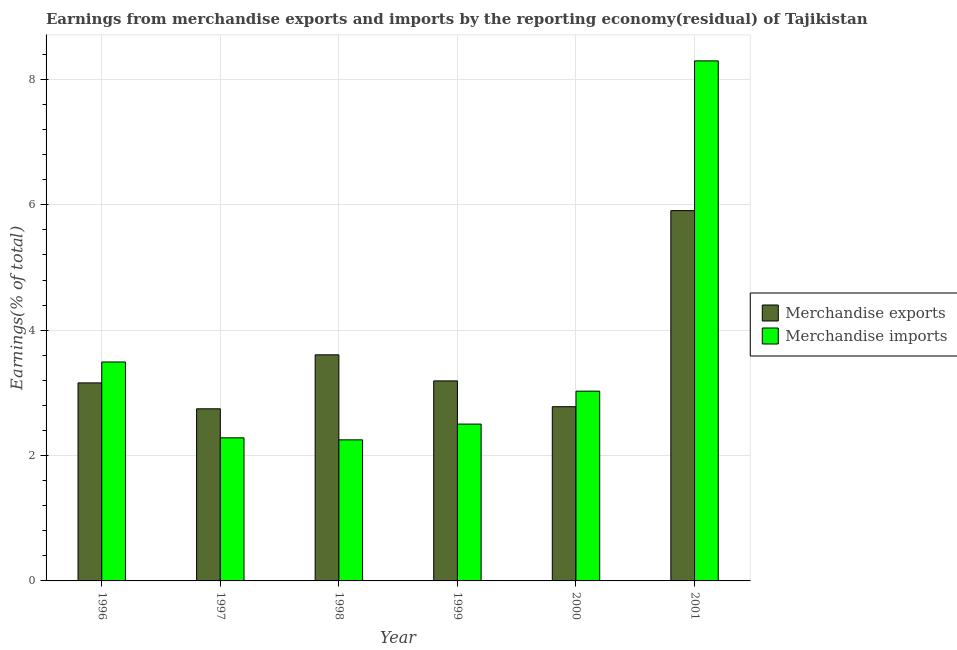How many different coloured bars are there?
Your answer should be compact. 2. How many groups of bars are there?
Offer a very short reply. 6. Are the number of bars per tick equal to the number of legend labels?
Ensure brevity in your answer.  Yes. Are the number of bars on each tick of the X-axis equal?
Your answer should be very brief. Yes. How many bars are there on the 4th tick from the left?
Give a very brief answer. 2. How many bars are there on the 5th tick from the right?
Keep it short and to the point. 2. What is the label of the 6th group of bars from the left?
Offer a terse response. 2001. What is the earnings from merchandise exports in 1999?
Offer a terse response. 3.19. Across all years, what is the maximum earnings from merchandise exports?
Provide a succinct answer. 5.91. Across all years, what is the minimum earnings from merchandise imports?
Your answer should be compact. 2.25. In which year was the earnings from merchandise exports maximum?
Offer a very short reply. 2001. In which year was the earnings from merchandise imports minimum?
Give a very brief answer. 1998. What is the total earnings from merchandise exports in the graph?
Offer a very short reply. 21.39. What is the difference between the earnings from merchandise exports in 1996 and that in 1999?
Ensure brevity in your answer.  -0.03. What is the difference between the earnings from merchandise imports in 2000 and the earnings from merchandise exports in 1998?
Your answer should be compact. 0.78. What is the average earnings from merchandise imports per year?
Your answer should be very brief. 3.64. In the year 1998, what is the difference between the earnings from merchandise imports and earnings from merchandise exports?
Offer a terse response. 0. In how many years, is the earnings from merchandise exports greater than 6.8 %?
Provide a succinct answer. 0. What is the ratio of the earnings from merchandise imports in 1997 to that in 2001?
Give a very brief answer. 0.28. What is the difference between the highest and the second highest earnings from merchandise imports?
Your answer should be very brief. 4.8. What is the difference between the highest and the lowest earnings from merchandise exports?
Offer a terse response. 3.16. In how many years, is the earnings from merchandise exports greater than the average earnings from merchandise exports taken over all years?
Ensure brevity in your answer.  2. What does the 2nd bar from the left in 1999 represents?
Give a very brief answer. Merchandise imports. What does the 2nd bar from the right in 1999 represents?
Offer a very short reply. Merchandise exports. How many bars are there?
Keep it short and to the point. 12. Are all the bars in the graph horizontal?
Your response must be concise. No. What is the difference between two consecutive major ticks on the Y-axis?
Ensure brevity in your answer.  2. Does the graph contain grids?
Provide a succinct answer. Yes. Where does the legend appear in the graph?
Offer a terse response. Center right. How are the legend labels stacked?
Give a very brief answer. Vertical. What is the title of the graph?
Offer a very short reply. Earnings from merchandise exports and imports by the reporting economy(residual) of Tajikistan. Does "Male" appear as one of the legend labels in the graph?
Offer a terse response. No. What is the label or title of the X-axis?
Provide a succinct answer. Year. What is the label or title of the Y-axis?
Offer a very short reply. Earnings(% of total). What is the Earnings(% of total) in Merchandise exports in 1996?
Your response must be concise. 3.16. What is the Earnings(% of total) of Merchandise imports in 1996?
Offer a terse response. 3.49. What is the Earnings(% of total) of Merchandise exports in 1997?
Ensure brevity in your answer.  2.75. What is the Earnings(% of total) in Merchandise imports in 1997?
Your answer should be very brief. 2.28. What is the Earnings(% of total) of Merchandise exports in 1998?
Keep it short and to the point. 3.61. What is the Earnings(% of total) of Merchandise imports in 1998?
Provide a succinct answer. 2.25. What is the Earnings(% of total) in Merchandise exports in 1999?
Ensure brevity in your answer.  3.19. What is the Earnings(% of total) in Merchandise imports in 1999?
Provide a short and direct response. 2.5. What is the Earnings(% of total) of Merchandise exports in 2000?
Offer a terse response. 2.78. What is the Earnings(% of total) in Merchandise imports in 2000?
Give a very brief answer. 3.03. What is the Earnings(% of total) in Merchandise exports in 2001?
Offer a terse response. 5.91. What is the Earnings(% of total) in Merchandise imports in 2001?
Your answer should be compact. 8.3. Across all years, what is the maximum Earnings(% of total) in Merchandise exports?
Offer a terse response. 5.91. Across all years, what is the maximum Earnings(% of total) in Merchandise imports?
Your answer should be compact. 8.3. Across all years, what is the minimum Earnings(% of total) in Merchandise exports?
Keep it short and to the point. 2.75. Across all years, what is the minimum Earnings(% of total) of Merchandise imports?
Your answer should be very brief. 2.25. What is the total Earnings(% of total) of Merchandise exports in the graph?
Your answer should be very brief. 21.39. What is the total Earnings(% of total) of Merchandise imports in the graph?
Offer a very short reply. 21.85. What is the difference between the Earnings(% of total) in Merchandise exports in 1996 and that in 1997?
Provide a succinct answer. 0.41. What is the difference between the Earnings(% of total) in Merchandise imports in 1996 and that in 1997?
Provide a short and direct response. 1.21. What is the difference between the Earnings(% of total) in Merchandise exports in 1996 and that in 1998?
Give a very brief answer. -0.45. What is the difference between the Earnings(% of total) of Merchandise imports in 1996 and that in 1998?
Your answer should be compact. 1.24. What is the difference between the Earnings(% of total) in Merchandise exports in 1996 and that in 1999?
Ensure brevity in your answer.  -0.03. What is the difference between the Earnings(% of total) of Merchandise imports in 1996 and that in 1999?
Make the answer very short. 0.99. What is the difference between the Earnings(% of total) of Merchandise exports in 1996 and that in 2000?
Offer a terse response. 0.38. What is the difference between the Earnings(% of total) of Merchandise imports in 1996 and that in 2000?
Offer a very short reply. 0.47. What is the difference between the Earnings(% of total) in Merchandise exports in 1996 and that in 2001?
Give a very brief answer. -2.75. What is the difference between the Earnings(% of total) in Merchandise imports in 1996 and that in 2001?
Your answer should be compact. -4.8. What is the difference between the Earnings(% of total) of Merchandise exports in 1997 and that in 1998?
Offer a terse response. -0.86. What is the difference between the Earnings(% of total) of Merchandise imports in 1997 and that in 1998?
Offer a terse response. 0.03. What is the difference between the Earnings(% of total) in Merchandise exports in 1997 and that in 1999?
Ensure brevity in your answer.  -0.45. What is the difference between the Earnings(% of total) in Merchandise imports in 1997 and that in 1999?
Provide a short and direct response. -0.22. What is the difference between the Earnings(% of total) of Merchandise exports in 1997 and that in 2000?
Offer a very short reply. -0.03. What is the difference between the Earnings(% of total) in Merchandise imports in 1997 and that in 2000?
Your response must be concise. -0.74. What is the difference between the Earnings(% of total) of Merchandise exports in 1997 and that in 2001?
Give a very brief answer. -3.16. What is the difference between the Earnings(% of total) of Merchandise imports in 1997 and that in 2001?
Offer a very short reply. -6.01. What is the difference between the Earnings(% of total) of Merchandise exports in 1998 and that in 1999?
Provide a short and direct response. 0.42. What is the difference between the Earnings(% of total) of Merchandise imports in 1998 and that in 1999?
Give a very brief answer. -0.25. What is the difference between the Earnings(% of total) in Merchandise exports in 1998 and that in 2000?
Your answer should be very brief. 0.83. What is the difference between the Earnings(% of total) of Merchandise imports in 1998 and that in 2000?
Ensure brevity in your answer.  -0.78. What is the difference between the Earnings(% of total) in Merchandise exports in 1998 and that in 2001?
Your response must be concise. -2.3. What is the difference between the Earnings(% of total) of Merchandise imports in 1998 and that in 2001?
Your answer should be compact. -6.05. What is the difference between the Earnings(% of total) of Merchandise exports in 1999 and that in 2000?
Your answer should be compact. 0.41. What is the difference between the Earnings(% of total) in Merchandise imports in 1999 and that in 2000?
Ensure brevity in your answer.  -0.53. What is the difference between the Earnings(% of total) of Merchandise exports in 1999 and that in 2001?
Make the answer very short. -2.72. What is the difference between the Earnings(% of total) of Merchandise imports in 1999 and that in 2001?
Make the answer very short. -5.79. What is the difference between the Earnings(% of total) in Merchandise exports in 2000 and that in 2001?
Keep it short and to the point. -3.13. What is the difference between the Earnings(% of total) of Merchandise imports in 2000 and that in 2001?
Your answer should be compact. -5.27. What is the difference between the Earnings(% of total) of Merchandise exports in 1996 and the Earnings(% of total) of Merchandise imports in 1997?
Make the answer very short. 0.88. What is the difference between the Earnings(% of total) of Merchandise exports in 1996 and the Earnings(% of total) of Merchandise imports in 1998?
Provide a short and direct response. 0.91. What is the difference between the Earnings(% of total) of Merchandise exports in 1996 and the Earnings(% of total) of Merchandise imports in 1999?
Provide a succinct answer. 0.66. What is the difference between the Earnings(% of total) of Merchandise exports in 1996 and the Earnings(% of total) of Merchandise imports in 2000?
Offer a very short reply. 0.13. What is the difference between the Earnings(% of total) in Merchandise exports in 1996 and the Earnings(% of total) in Merchandise imports in 2001?
Keep it short and to the point. -5.14. What is the difference between the Earnings(% of total) of Merchandise exports in 1997 and the Earnings(% of total) of Merchandise imports in 1998?
Your answer should be very brief. 0.5. What is the difference between the Earnings(% of total) of Merchandise exports in 1997 and the Earnings(% of total) of Merchandise imports in 1999?
Your answer should be very brief. 0.24. What is the difference between the Earnings(% of total) in Merchandise exports in 1997 and the Earnings(% of total) in Merchandise imports in 2000?
Offer a very short reply. -0.28. What is the difference between the Earnings(% of total) of Merchandise exports in 1997 and the Earnings(% of total) of Merchandise imports in 2001?
Your answer should be very brief. -5.55. What is the difference between the Earnings(% of total) of Merchandise exports in 1998 and the Earnings(% of total) of Merchandise imports in 1999?
Offer a very short reply. 1.1. What is the difference between the Earnings(% of total) in Merchandise exports in 1998 and the Earnings(% of total) in Merchandise imports in 2000?
Make the answer very short. 0.58. What is the difference between the Earnings(% of total) in Merchandise exports in 1998 and the Earnings(% of total) in Merchandise imports in 2001?
Offer a terse response. -4.69. What is the difference between the Earnings(% of total) in Merchandise exports in 1999 and the Earnings(% of total) in Merchandise imports in 2000?
Ensure brevity in your answer.  0.16. What is the difference between the Earnings(% of total) of Merchandise exports in 1999 and the Earnings(% of total) of Merchandise imports in 2001?
Provide a short and direct response. -5.11. What is the difference between the Earnings(% of total) in Merchandise exports in 2000 and the Earnings(% of total) in Merchandise imports in 2001?
Your answer should be compact. -5.52. What is the average Earnings(% of total) in Merchandise exports per year?
Give a very brief answer. 3.56. What is the average Earnings(% of total) in Merchandise imports per year?
Provide a succinct answer. 3.64. In the year 1996, what is the difference between the Earnings(% of total) in Merchandise exports and Earnings(% of total) in Merchandise imports?
Give a very brief answer. -0.33. In the year 1997, what is the difference between the Earnings(% of total) in Merchandise exports and Earnings(% of total) in Merchandise imports?
Give a very brief answer. 0.46. In the year 1998, what is the difference between the Earnings(% of total) of Merchandise exports and Earnings(% of total) of Merchandise imports?
Offer a terse response. 1.36. In the year 1999, what is the difference between the Earnings(% of total) of Merchandise exports and Earnings(% of total) of Merchandise imports?
Keep it short and to the point. 0.69. In the year 2000, what is the difference between the Earnings(% of total) in Merchandise exports and Earnings(% of total) in Merchandise imports?
Offer a very short reply. -0.25. In the year 2001, what is the difference between the Earnings(% of total) of Merchandise exports and Earnings(% of total) of Merchandise imports?
Your response must be concise. -2.39. What is the ratio of the Earnings(% of total) in Merchandise exports in 1996 to that in 1997?
Your answer should be very brief. 1.15. What is the ratio of the Earnings(% of total) of Merchandise imports in 1996 to that in 1997?
Provide a short and direct response. 1.53. What is the ratio of the Earnings(% of total) in Merchandise exports in 1996 to that in 1998?
Your answer should be compact. 0.88. What is the ratio of the Earnings(% of total) of Merchandise imports in 1996 to that in 1998?
Offer a very short reply. 1.55. What is the ratio of the Earnings(% of total) of Merchandise exports in 1996 to that in 1999?
Offer a very short reply. 0.99. What is the ratio of the Earnings(% of total) in Merchandise imports in 1996 to that in 1999?
Offer a terse response. 1.4. What is the ratio of the Earnings(% of total) of Merchandise exports in 1996 to that in 2000?
Ensure brevity in your answer.  1.14. What is the ratio of the Earnings(% of total) in Merchandise imports in 1996 to that in 2000?
Keep it short and to the point. 1.15. What is the ratio of the Earnings(% of total) of Merchandise exports in 1996 to that in 2001?
Your answer should be very brief. 0.53. What is the ratio of the Earnings(% of total) of Merchandise imports in 1996 to that in 2001?
Provide a short and direct response. 0.42. What is the ratio of the Earnings(% of total) of Merchandise exports in 1997 to that in 1998?
Your answer should be compact. 0.76. What is the ratio of the Earnings(% of total) of Merchandise imports in 1997 to that in 1998?
Give a very brief answer. 1.01. What is the ratio of the Earnings(% of total) of Merchandise exports in 1997 to that in 1999?
Make the answer very short. 0.86. What is the ratio of the Earnings(% of total) of Merchandise imports in 1997 to that in 1999?
Provide a succinct answer. 0.91. What is the ratio of the Earnings(% of total) of Merchandise exports in 1997 to that in 2000?
Provide a succinct answer. 0.99. What is the ratio of the Earnings(% of total) in Merchandise imports in 1997 to that in 2000?
Your response must be concise. 0.75. What is the ratio of the Earnings(% of total) of Merchandise exports in 1997 to that in 2001?
Provide a short and direct response. 0.46. What is the ratio of the Earnings(% of total) in Merchandise imports in 1997 to that in 2001?
Keep it short and to the point. 0.28. What is the ratio of the Earnings(% of total) in Merchandise exports in 1998 to that in 1999?
Offer a very short reply. 1.13. What is the ratio of the Earnings(% of total) in Merchandise imports in 1998 to that in 1999?
Ensure brevity in your answer.  0.9. What is the ratio of the Earnings(% of total) of Merchandise exports in 1998 to that in 2000?
Your answer should be very brief. 1.3. What is the ratio of the Earnings(% of total) in Merchandise imports in 1998 to that in 2000?
Make the answer very short. 0.74. What is the ratio of the Earnings(% of total) in Merchandise exports in 1998 to that in 2001?
Keep it short and to the point. 0.61. What is the ratio of the Earnings(% of total) in Merchandise imports in 1998 to that in 2001?
Offer a very short reply. 0.27. What is the ratio of the Earnings(% of total) in Merchandise exports in 1999 to that in 2000?
Offer a terse response. 1.15. What is the ratio of the Earnings(% of total) in Merchandise imports in 1999 to that in 2000?
Give a very brief answer. 0.83. What is the ratio of the Earnings(% of total) in Merchandise exports in 1999 to that in 2001?
Offer a very short reply. 0.54. What is the ratio of the Earnings(% of total) of Merchandise imports in 1999 to that in 2001?
Give a very brief answer. 0.3. What is the ratio of the Earnings(% of total) of Merchandise exports in 2000 to that in 2001?
Your answer should be compact. 0.47. What is the ratio of the Earnings(% of total) in Merchandise imports in 2000 to that in 2001?
Ensure brevity in your answer.  0.36. What is the difference between the highest and the second highest Earnings(% of total) in Merchandise exports?
Your answer should be compact. 2.3. What is the difference between the highest and the second highest Earnings(% of total) of Merchandise imports?
Your answer should be compact. 4.8. What is the difference between the highest and the lowest Earnings(% of total) of Merchandise exports?
Ensure brevity in your answer.  3.16. What is the difference between the highest and the lowest Earnings(% of total) in Merchandise imports?
Your answer should be compact. 6.05. 